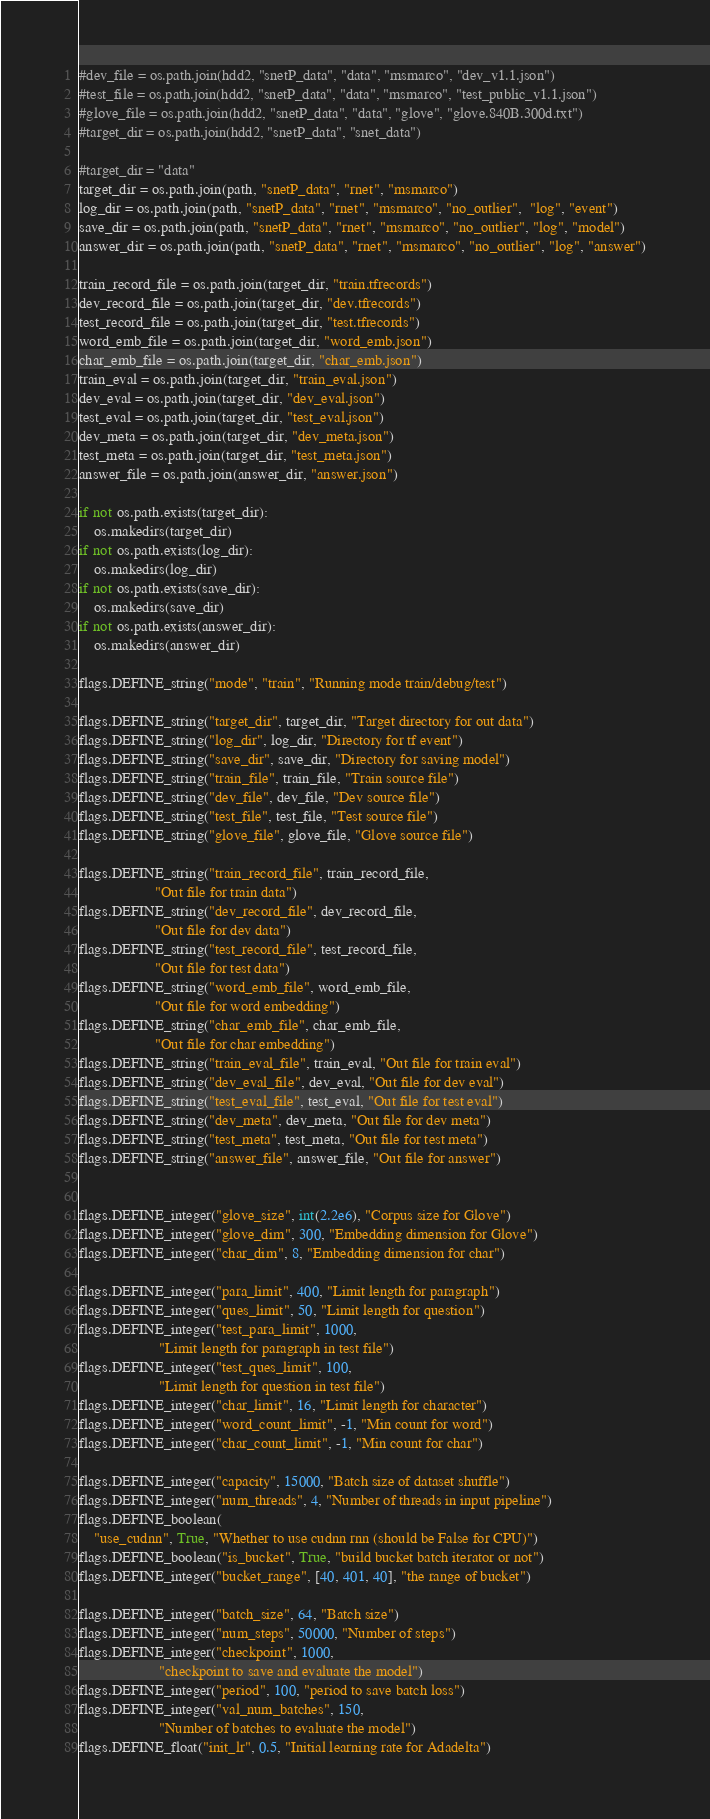<code> <loc_0><loc_0><loc_500><loc_500><_Python_>#dev_file = os.path.join(hdd2, "snetP_data", "data", "msmarco", "dev_v1.1.json")
#test_file = os.path.join(hdd2, "snetP_data", "data", "msmarco", "test_public_v1.1.json")
#glove_file = os.path.join(hdd2, "snetP_data", "data", "glove", "glove.840B.300d.txt")
#target_dir = os.path.join(hdd2, "snetP_data", "snet_data")

#target_dir = "data"
target_dir = os.path.join(path, "snetP_data", "rnet", "msmarco")
log_dir = os.path.join(path, "snetP_data", "rnet", "msmarco", "no_outlier",  "log", "event")
save_dir = os.path.join(path, "snetP_data", "rnet", "msmarco", "no_outlier", "log", "model")
answer_dir = os.path.join(path, "snetP_data", "rnet", "msmarco", "no_outlier", "log", "answer")

train_record_file = os.path.join(target_dir, "train.tfrecords")
dev_record_file = os.path.join(target_dir, "dev.tfrecords")
test_record_file = os.path.join(target_dir, "test.tfrecords")
word_emb_file = os.path.join(target_dir, "word_emb.json")
char_emb_file = os.path.join(target_dir, "char_emb.json")
train_eval = os.path.join(target_dir, "train_eval.json")
dev_eval = os.path.join(target_dir, "dev_eval.json")
test_eval = os.path.join(target_dir, "test_eval.json")
dev_meta = os.path.join(target_dir, "dev_meta.json")
test_meta = os.path.join(target_dir, "test_meta.json")
answer_file = os.path.join(answer_dir, "answer.json")

if not os.path.exists(target_dir):
    os.makedirs(target_dir)
if not os.path.exists(log_dir):
    os.makedirs(log_dir)
if not os.path.exists(save_dir):
    os.makedirs(save_dir)
if not os.path.exists(answer_dir):
    os.makedirs(answer_dir)

flags.DEFINE_string("mode", "train", "Running mode train/debug/test")

flags.DEFINE_string("target_dir", target_dir, "Target directory for out data")
flags.DEFINE_string("log_dir", log_dir, "Directory for tf event")
flags.DEFINE_string("save_dir", save_dir, "Directory for saving model")
flags.DEFINE_string("train_file", train_file, "Train source file")
flags.DEFINE_string("dev_file", dev_file, "Dev source file")
flags.DEFINE_string("test_file", test_file, "Test source file")
flags.DEFINE_string("glove_file", glove_file, "Glove source file")

flags.DEFINE_string("train_record_file", train_record_file,
                    "Out file for train data")
flags.DEFINE_string("dev_record_file", dev_record_file,
                    "Out file for dev data")
flags.DEFINE_string("test_record_file", test_record_file,
                    "Out file for test data")
flags.DEFINE_string("word_emb_file", word_emb_file,
                    "Out file for word embedding")
flags.DEFINE_string("char_emb_file", char_emb_file,
                    "Out file for char embedding")
flags.DEFINE_string("train_eval_file", train_eval, "Out file for train eval")
flags.DEFINE_string("dev_eval_file", dev_eval, "Out file for dev eval")
flags.DEFINE_string("test_eval_file", test_eval, "Out file for test eval")
flags.DEFINE_string("dev_meta", dev_meta, "Out file for dev meta")
flags.DEFINE_string("test_meta", test_meta, "Out file for test meta")
flags.DEFINE_string("answer_file", answer_file, "Out file for answer")


flags.DEFINE_integer("glove_size", int(2.2e6), "Corpus size for Glove")
flags.DEFINE_integer("glove_dim", 300, "Embedding dimension for Glove")
flags.DEFINE_integer("char_dim", 8, "Embedding dimension for char")

flags.DEFINE_integer("para_limit", 400, "Limit length for paragraph")
flags.DEFINE_integer("ques_limit", 50, "Limit length for question")
flags.DEFINE_integer("test_para_limit", 1000,
                     "Limit length for paragraph in test file")
flags.DEFINE_integer("test_ques_limit", 100,
                     "Limit length for question in test file")
flags.DEFINE_integer("char_limit", 16, "Limit length for character")
flags.DEFINE_integer("word_count_limit", -1, "Min count for word")
flags.DEFINE_integer("char_count_limit", -1, "Min count for char")

flags.DEFINE_integer("capacity", 15000, "Batch size of dataset shuffle")
flags.DEFINE_integer("num_threads", 4, "Number of threads in input pipeline")
flags.DEFINE_boolean(
    "use_cudnn", True, "Whether to use cudnn rnn (should be False for CPU)")
flags.DEFINE_boolean("is_bucket", True, "build bucket batch iterator or not")
flags.DEFINE_integer("bucket_range", [40, 401, 40], "the range of bucket")

flags.DEFINE_integer("batch_size", 64, "Batch size")
flags.DEFINE_integer("num_steps", 50000, "Number of steps")
flags.DEFINE_integer("checkpoint", 1000,
                     "checkpoint to save and evaluate the model")
flags.DEFINE_integer("period", 100, "period to save batch loss")
flags.DEFINE_integer("val_num_batches", 150,
                     "Number of batches to evaluate the model")
flags.DEFINE_float("init_lr", 0.5, "Initial learning rate for Adadelta")</code> 